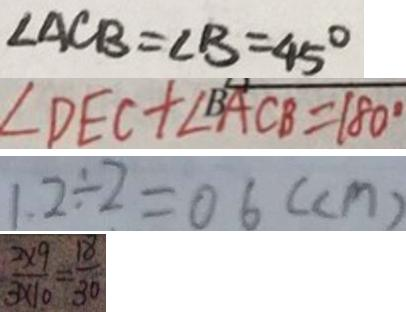Convert formula to latex. <formula><loc_0><loc_0><loc_500><loc_500>\angle A C B = \angle B = 4 5 ^ { \circ } 
 \angle D E C + \angle B A C B = 1 8 0 ^ { \circ } 
 1 . 2 \div 2 = 0 6 ( c m ) 
 \frac { 2 \times 9 } { 3 \times 1 0 } = \frac { 1 8 } { 3 0 }</formula> 